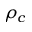Convert formula to latex. <formula><loc_0><loc_0><loc_500><loc_500>\rho _ { c }</formula> 